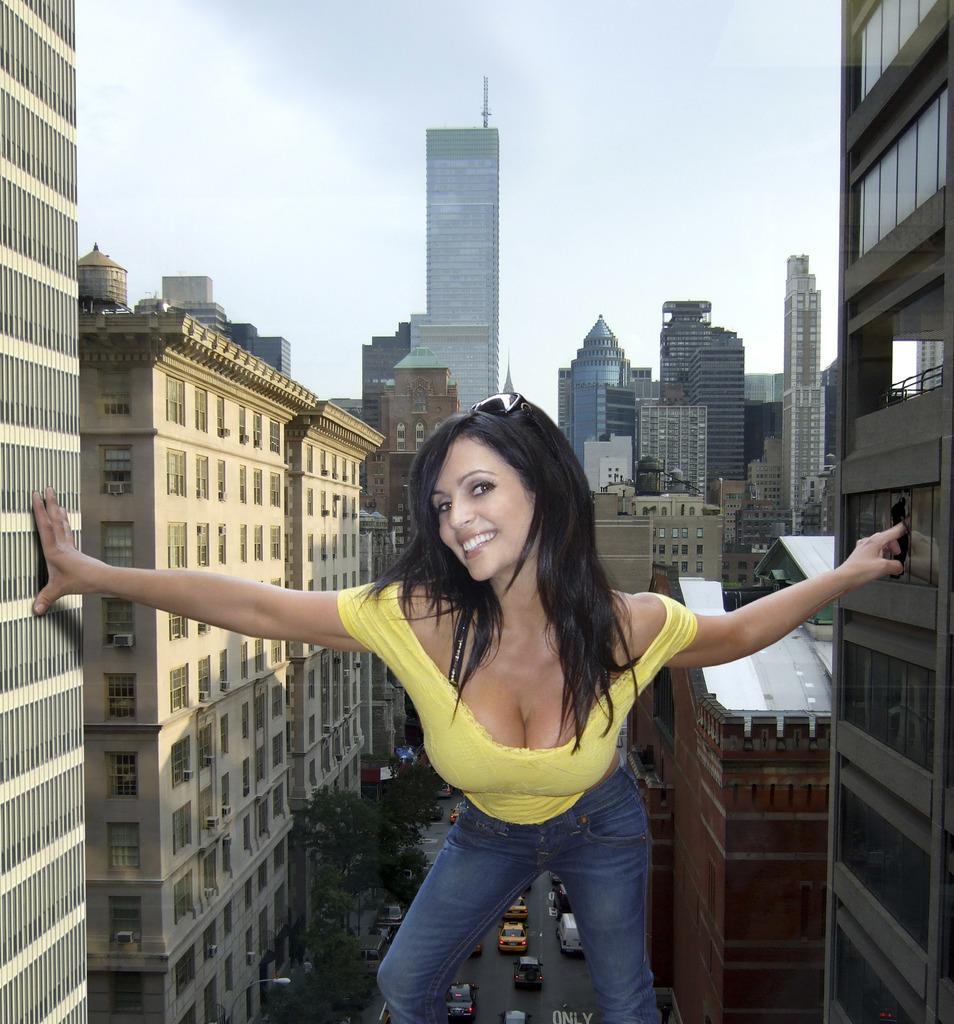Describe this image in one or two sentences. In this image we can see a woman and she is smiling. Here we can see buildings, trees, and vehicles on the road. In the background there is sky. 